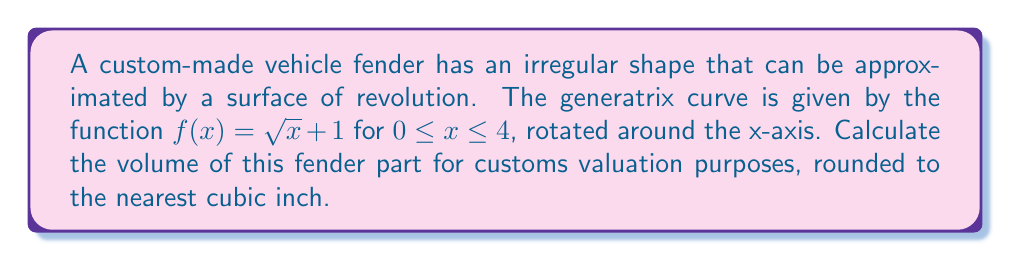Teach me how to tackle this problem. To calculate the volume of this irregularly shaped vehicle part, we'll use the formula for the volume of a solid of revolution:

$$V = \pi \int_a^b [f(x)]^2 dx$$

Where $f(x)$ is the generatrix curve, and $[a,b]$ is the interval over which we're integrating.

Steps:
1) Our function is $f(x) = \sqrt{x} + 1$, and we're integrating from $a=0$ to $b=4$.

2) Substitute into the volume formula:
   $$V = \pi \int_0^4 (\sqrt{x} + 1)^2 dx$$

3) Expand the squared term:
   $$V = \pi \int_0^4 (x + 2\sqrt{x} + 1) dx$$

4) Integrate each term:
   $$V = \pi \left[\frac{1}{2}x^2 + \frac{4}{3}x^{3/2} + x\right]_0^4$$

5) Evaluate the integral:
   $$V = \pi \left[\frac{1}{2}(4^2) + \frac{4}{3}(4^{3/2}) + 4 - (0 + 0 + 0)\right]$$
   $$V = \pi \left[8 + \frac{32}{3} + 4\right]$$
   $$V = \pi \left[12 + \frac{32}{3}\right]$$
   $$V = \pi \left[\frac{36 + 32}{3}\right]$$
   $$V = \pi \cdot \frac{68}{3}$$

6) Calculate and round to the nearest cubic inch:
   $$V \approx 71.12 \text{ cubic inches}$$
   Rounded to the nearest cubic inch: 71 cubic inches.
Answer: 71 cubic inches 